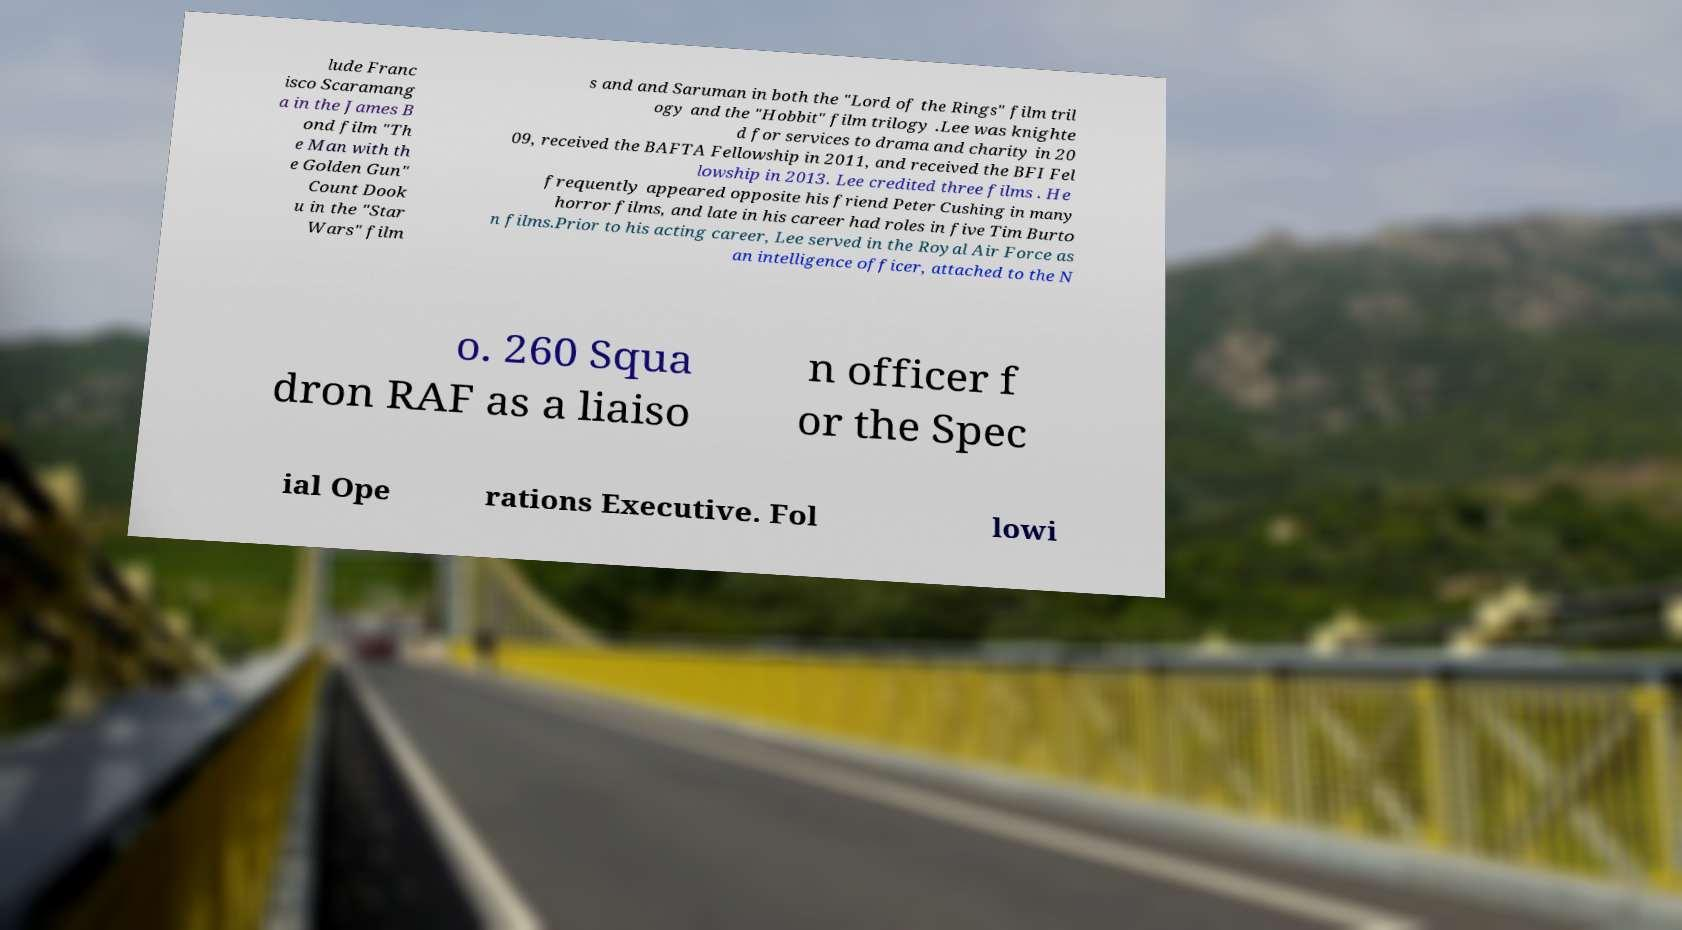Can you accurately transcribe the text from the provided image for me? lude Franc isco Scaramang a in the James B ond film "Th e Man with th e Golden Gun" Count Dook u in the "Star Wars" film s and and Saruman in both the "Lord of the Rings" film tril ogy and the "Hobbit" film trilogy .Lee was knighte d for services to drama and charity in 20 09, received the BAFTA Fellowship in 2011, and received the BFI Fel lowship in 2013. Lee credited three films . He frequently appeared opposite his friend Peter Cushing in many horror films, and late in his career had roles in five Tim Burto n films.Prior to his acting career, Lee served in the Royal Air Force as an intelligence officer, attached to the N o. 260 Squa dron RAF as a liaiso n officer f or the Spec ial Ope rations Executive. Fol lowi 